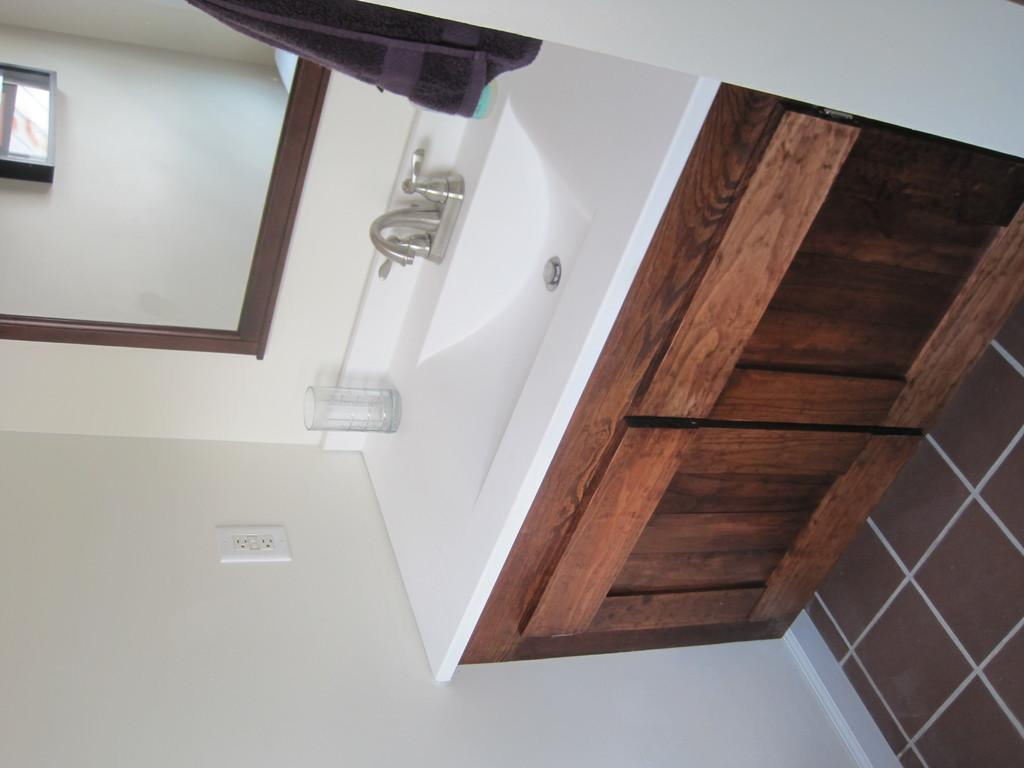What can be seen on the wash basin in the image? There is a tumbler on the wash basin in the image. What is located below the wash basin? There is a cupboard below the wash basin. What is used for personal grooming in the image? There is a mirror in the image. What is used for drying hands in the image? There is a towel in the image. What is present on the wall in the image? There is a switch board on the wall. What type of flame can be seen on the brother's head in the image? There is no brother or flame present in the image. 